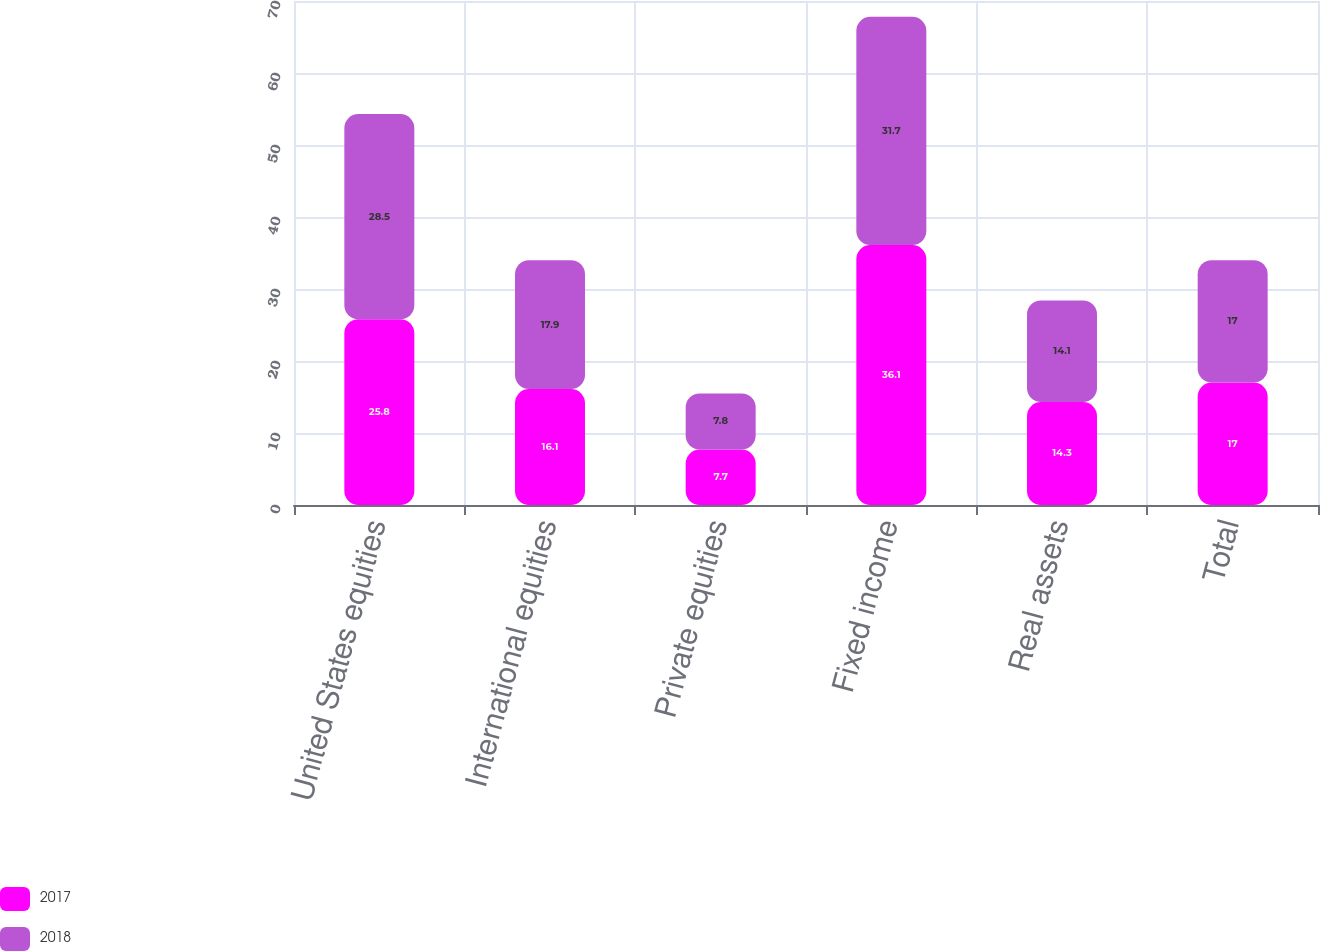<chart> <loc_0><loc_0><loc_500><loc_500><stacked_bar_chart><ecel><fcel>United States equities<fcel>International equities<fcel>Private equities<fcel>Fixed income<fcel>Real assets<fcel>Total<nl><fcel>2017<fcel>25.8<fcel>16.1<fcel>7.7<fcel>36.1<fcel>14.3<fcel>17<nl><fcel>2018<fcel>28.5<fcel>17.9<fcel>7.8<fcel>31.7<fcel>14.1<fcel>17<nl></chart> 